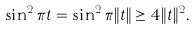<formula> <loc_0><loc_0><loc_500><loc_500>\sin ^ { 2 } \pi t = \sin ^ { 2 } \pi \| t \| \geq 4 \| t \| ^ { 2 } .</formula> 